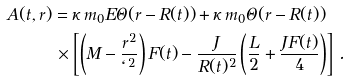Convert formula to latex. <formula><loc_0><loc_0><loc_500><loc_500>A ( t , r ) & = \kappa \, m _ { 0 } E \Theta ( r - R ( t ) ) + \kappa \, m _ { 0 } \Theta ( r - R ( t ) ) \\ & \, \times \left [ \left ( M - \frac { r ^ { 2 } } { \ell ^ { 2 } } \right ) F ( t ) - \frac { J } { R ( t ) ^ { 2 } } \left ( \frac { L } { 2 } + \frac { J F ( t ) } { 4 } \right ) \right ] \, .</formula> 